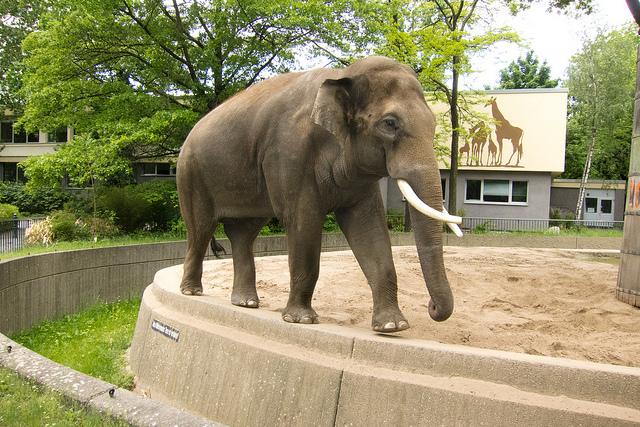What animal is this with husks?
Give a very brief answer. Elephant. Is there a building in the background?
Answer briefly. Yes. What surface is the elephant walking on?
Write a very short answer. Concrete. 